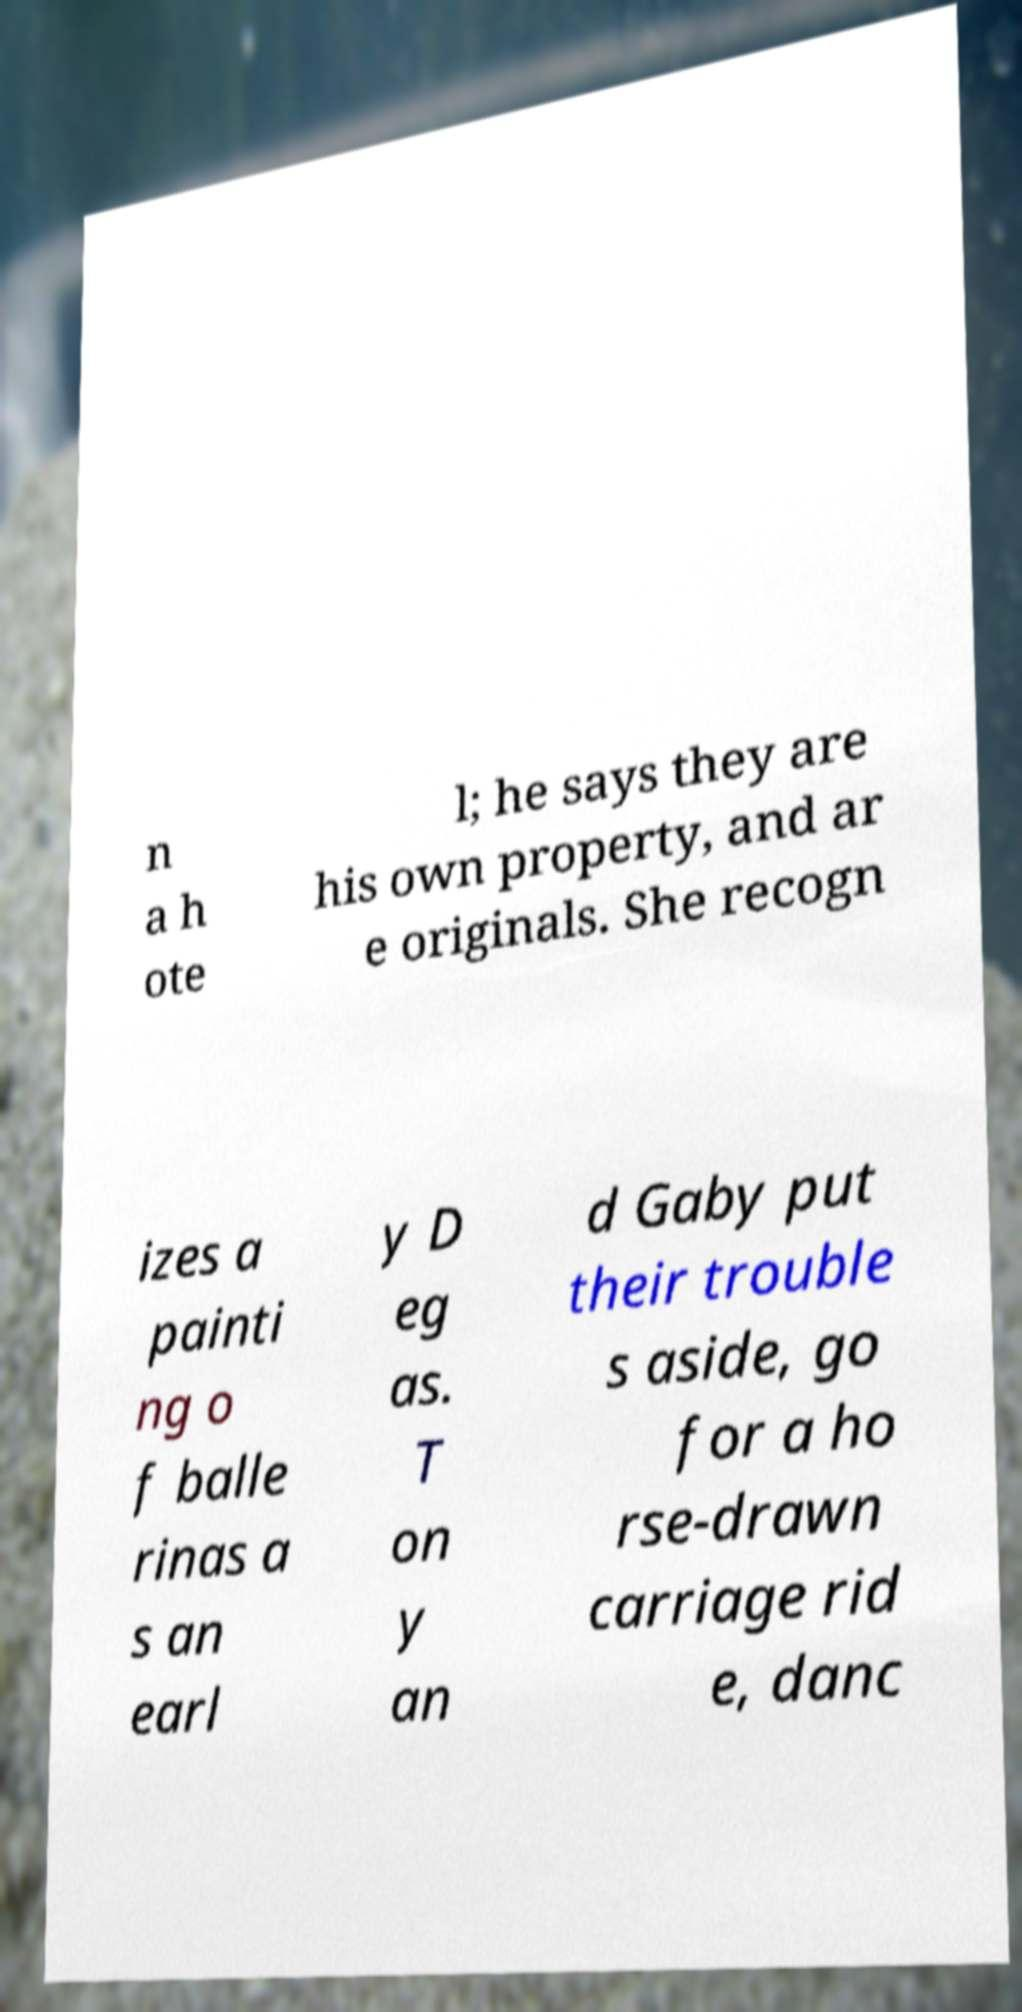Can you accurately transcribe the text from the provided image for me? n a h ote l; he says they are his own property, and ar e originals. She recogn izes a painti ng o f balle rinas a s an earl y D eg as. T on y an d Gaby put their trouble s aside, go for a ho rse-drawn carriage rid e, danc 